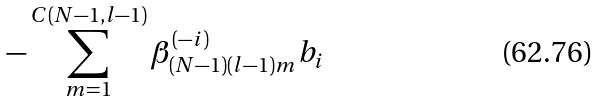Convert formula to latex. <formula><loc_0><loc_0><loc_500><loc_500>- \sum _ { m = 1 } ^ { C ( N - 1 , l - 1 ) } \beta _ { ( N - 1 ) ( l - 1 ) m } ^ { ( - i ) } b _ { i }</formula> 